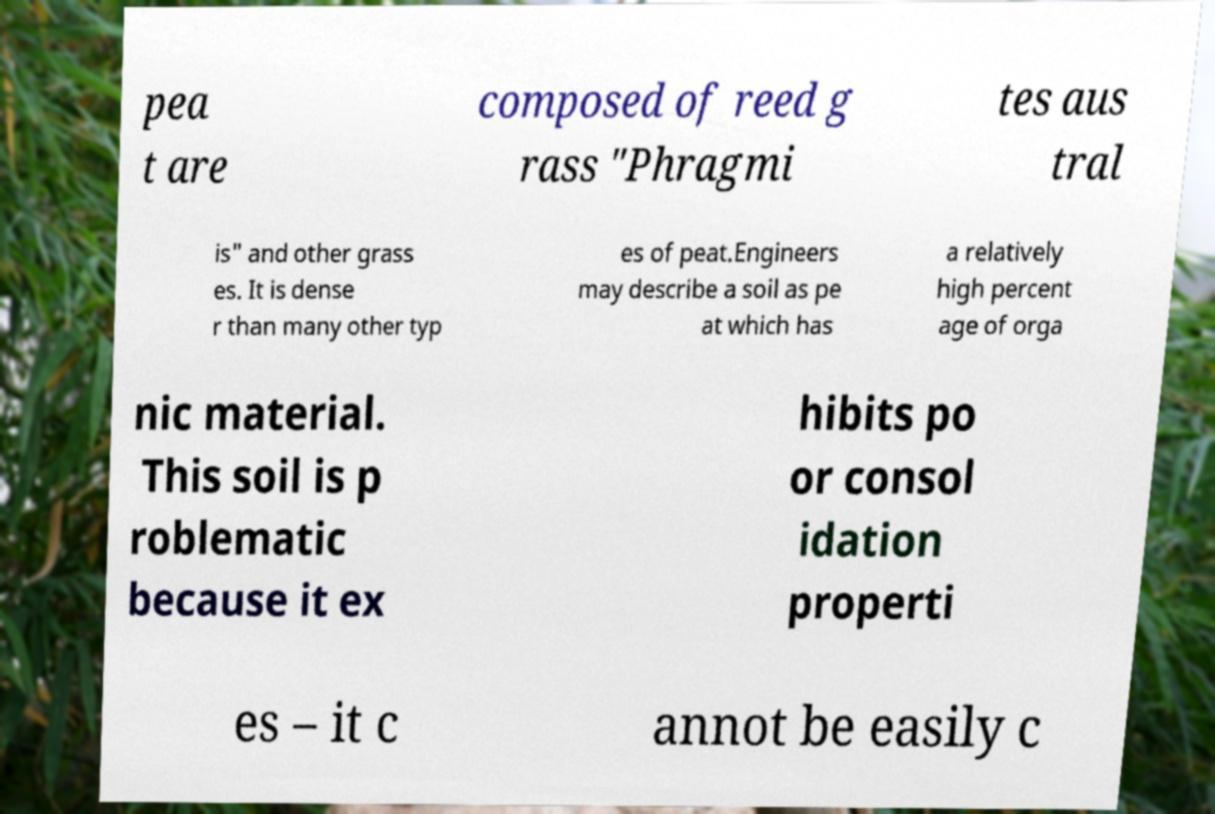There's text embedded in this image that I need extracted. Can you transcribe it verbatim? pea t are composed of reed g rass "Phragmi tes aus tral is" and other grass es. It is dense r than many other typ es of peat.Engineers may describe a soil as pe at which has a relatively high percent age of orga nic material. This soil is p roblematic because it ex hibits po or consol idation properti es – it c annot be easily c 